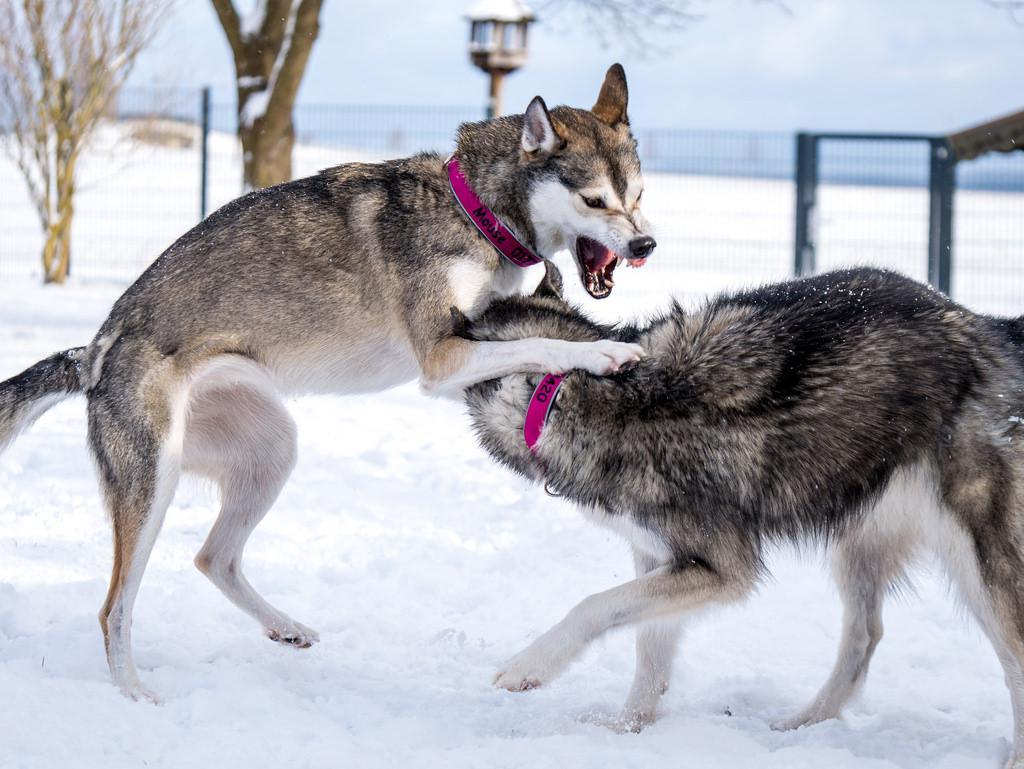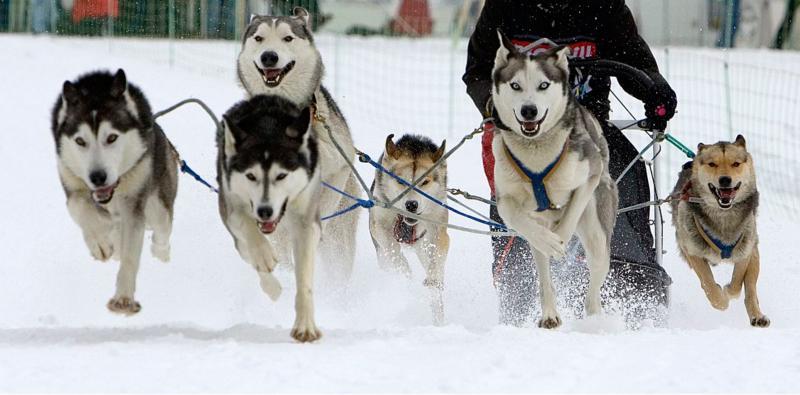The first image is the image on the left, the second image is the image on the right. Assess this claim about the two images: "one of the images contain only one wolf". Correct or not? Answer yes or no. No. 